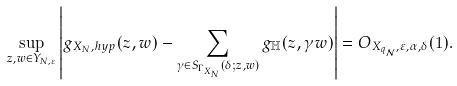Convert formula to latex. <formula><loc_0><loc_0><loc_500><loc_500>\sup _ { z , w \in Y _ { N , \varepsilon } } \left | g _ { X _ { N } , h y p } ( z , w ) - \sum _ { \gamma \in S _ { \Gamma _ { X _ { N } } } ( \delta ; z , w ) } g _ { \mathbb { H } } ( z , \gamma w ) \right | = O _ { X _ { q _ { \mathcal { N } } } , \varepsilon , \alpha , \delta } ( 1 ) .</formula> 